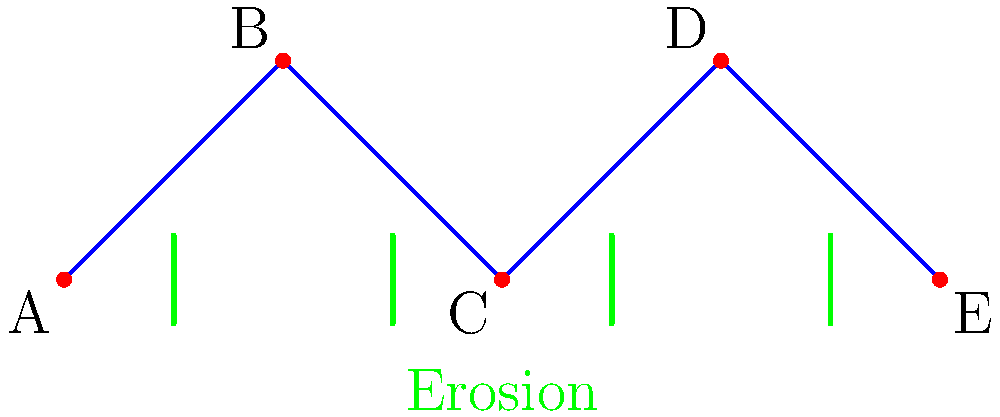In the network structure of logging roads shown above, where A, B, C, D, and E represent different logging sites connected by roads, and the green lines indicate areas of soil erosion, what is the minimum number of road segments that need to be closed to disconnect at least one logging site from the rest of the network while minimizing the impact on soil erosion? To answer this question, we need to analyze the network structure and the erosion indicators:

1. The network consists of 5 logging sites (A, B, C, D, E) connected by 4 road segments.
2. Erosion is present between each pair of adjacent sites, as indicated by the green lines.
3. To disconnect at least one logging site, we need to remove at least one road segment.
4. The goal is to minimize the impact on soil erosion while disconnecting a site.

Let's consider each road segment:
- Removing AB or DE would disconnect one site (A or E, respectively) but would only address one erosion area.
- Removing BC or CD would disconnect two sites (AB or DE, respectively) and address two erosion areas.

Therefore, to maximize the effect on both network disconnection and erosion mitigation, we should remove either BC or CD. Since we only need to remove one segment to meet the question's requirements, the minimum number of road segments to be closed is 1.

This solution would disconnect two logging sites from the rest of the network while addressing two areas of soil erosion, which is the most efficient approach given the network structure and erosion indicators.
Answer: 1 